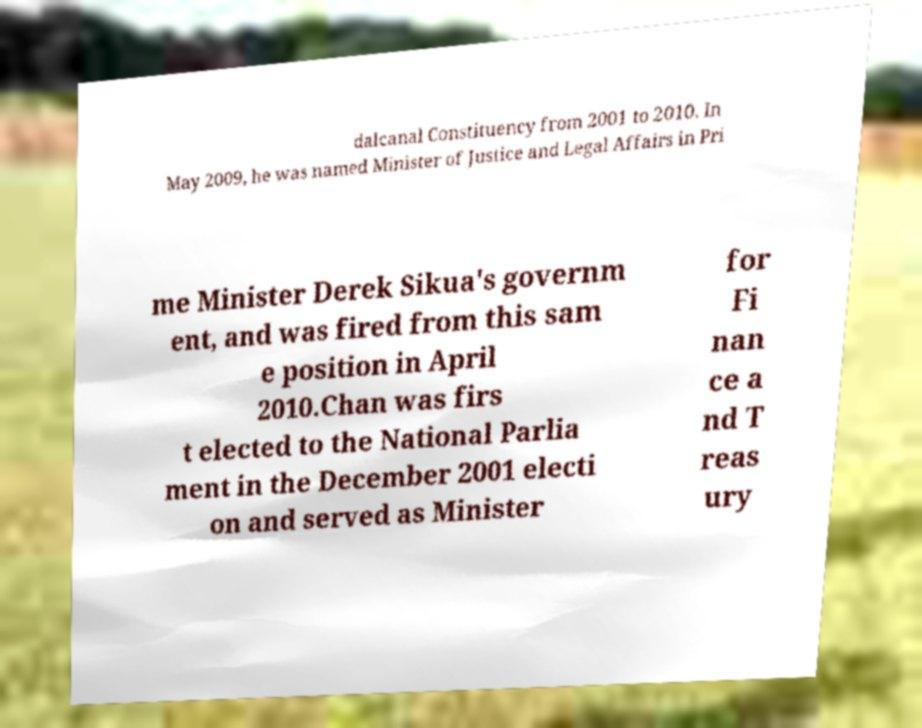For documentation purposes, I need the text within this image transcribed. Could you provide that? dalcanal Constituency from 2001 to 2010. In May 2009, he was named Minister of Justice and Legal Affairs in Pri me Minister Derek Sikua's governm ent, and was fired from this sam e position in April 2010.Chan was firs t elected to the National Parlia ment in the December 2001 electi on and served as Minister for Fi nan ce a nd T reas ury 